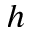Convert formula to latex. <formula><loc_0><loc_0><loc_500><loc_500>h</formula> 